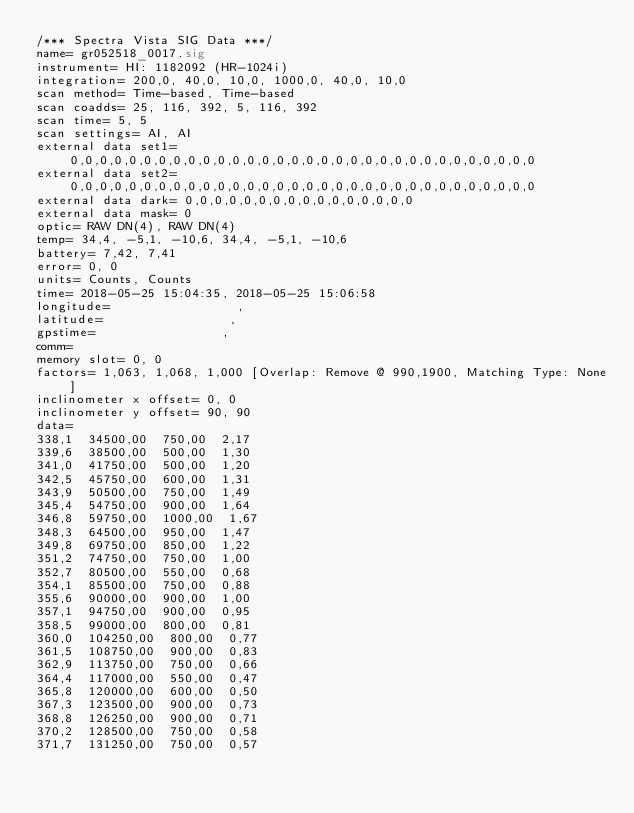Convert code to text. <code><loc_0><loc_0><loc_500><loc_500><_SML_>/*** Spectra Vista SIG Data ***/
name= gr052518_0017.sig
instrument= HI: 1182092 (HR-1024i)
integration= 200,0, 40,0, 10,0, 1000,0, 40,0, 10,0
scan method= Time-based, Time-based
scan coadds= 25, 116, 392, 5, 116, 392
scan time= 5, 5
scan settings= AI, AI
external data set1= 0,0,0,0,0,0,0,0,0,0,0,0,0,0,0,0,0,0,0,0,0,0,0,0,0,0,0,0,0,0,0,0
external data set2= 0,0,0,0,0,0,0,0,0,0,0,0,0,0,0,0,0,0,0,0,0,0,0,0,0,0,0,0,0,0,0,0
external data dark= 0,0,0,0,0,0,0,0,0,0,0,0,0,0,0,0
external data mask= 0
optic= RAW DN(4), RAW DN(4)
temp= 34,4, -5,1, -10,6, 34,4, -5,1, -10,6
battery= 7,42, 7,41
error= 0, 0
units= Counts, Counts
time= 2018-05-25 15:04:35, 2018-05-25 15:06:58
longitude=                 ,                 
latitude=                 ,                 
gpstime=                 ,                 
comm= 
memory slot= 0, 0
factors= 1,063, 1,068, 1,000 [Overlap: Remove @ 990,1900, Matching Type: None]
inclinometer x offset= 0, 0
inclinometer y offset= 90, 90
data= 
338,1  34500,00  750,00  2,17
339,6  38500,00  500,00  1,30
341,0  41750,00  500,00  1,20
342,5  45750,00  600,00  1,31
343,9  50500,00  750,00  1,49
345,4  54750,00  900,00  1,64
346,8  59750,00  1000,00  1,67
348,3  64500,00  950,00  1,47
349,8  69750,00  850,00  1,22
351,2  74750,00  750,00  1,00
352,7  80500,00  550,00  0,68
354,1  85500,00  750,00  0,88
355,6  90000,00  900,00  1,00
357,1  94750,00  900,00  0,95
358,5  99000,00  800,00  0,81
360,0  104250,00  800,00  0,77
361,5  108750,00  900,00  0,83
362,9  113750,00  750,00  0,66
364,4  117000,00  550,00  0,47
365,8  120000,00  600,00  0,50
367,3  123500,00  900,00  0,73
368,8  126250,00  900,00  0,71
370,2  128500,00  750,00  0,58
371,7  131250,00  750,00  0,57</code> 